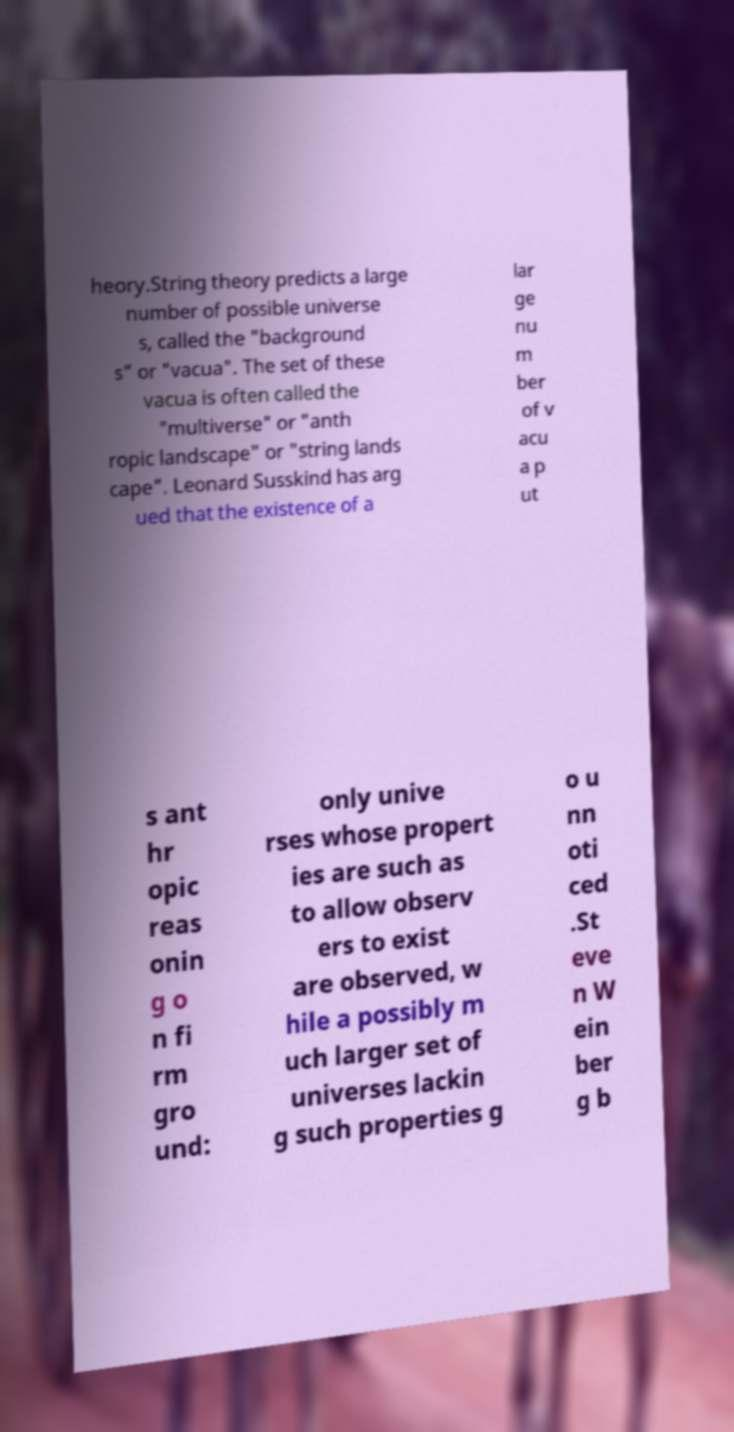There's text embedded in this image that I need extracted. Can you transcribe it verbatim? heory.String theory predicts a large number of possible universe s, called the "background s" or "vacua". The set of these vacua is often called the "multiverse" or "anth ropic landscape" or "string lands cape". Leonard Susskind has arg ued that the existence of a lar ge nu m ber of v acu a p ut s ant hr opic reas onin g o n fi rm gro und: only unive rses whose propert ies are such as to allow observ ers to exist are observed, w hile a possibly m uch larger set of universes lackin g such properties g o u nn oti ced .St eve n W ein ber g b 